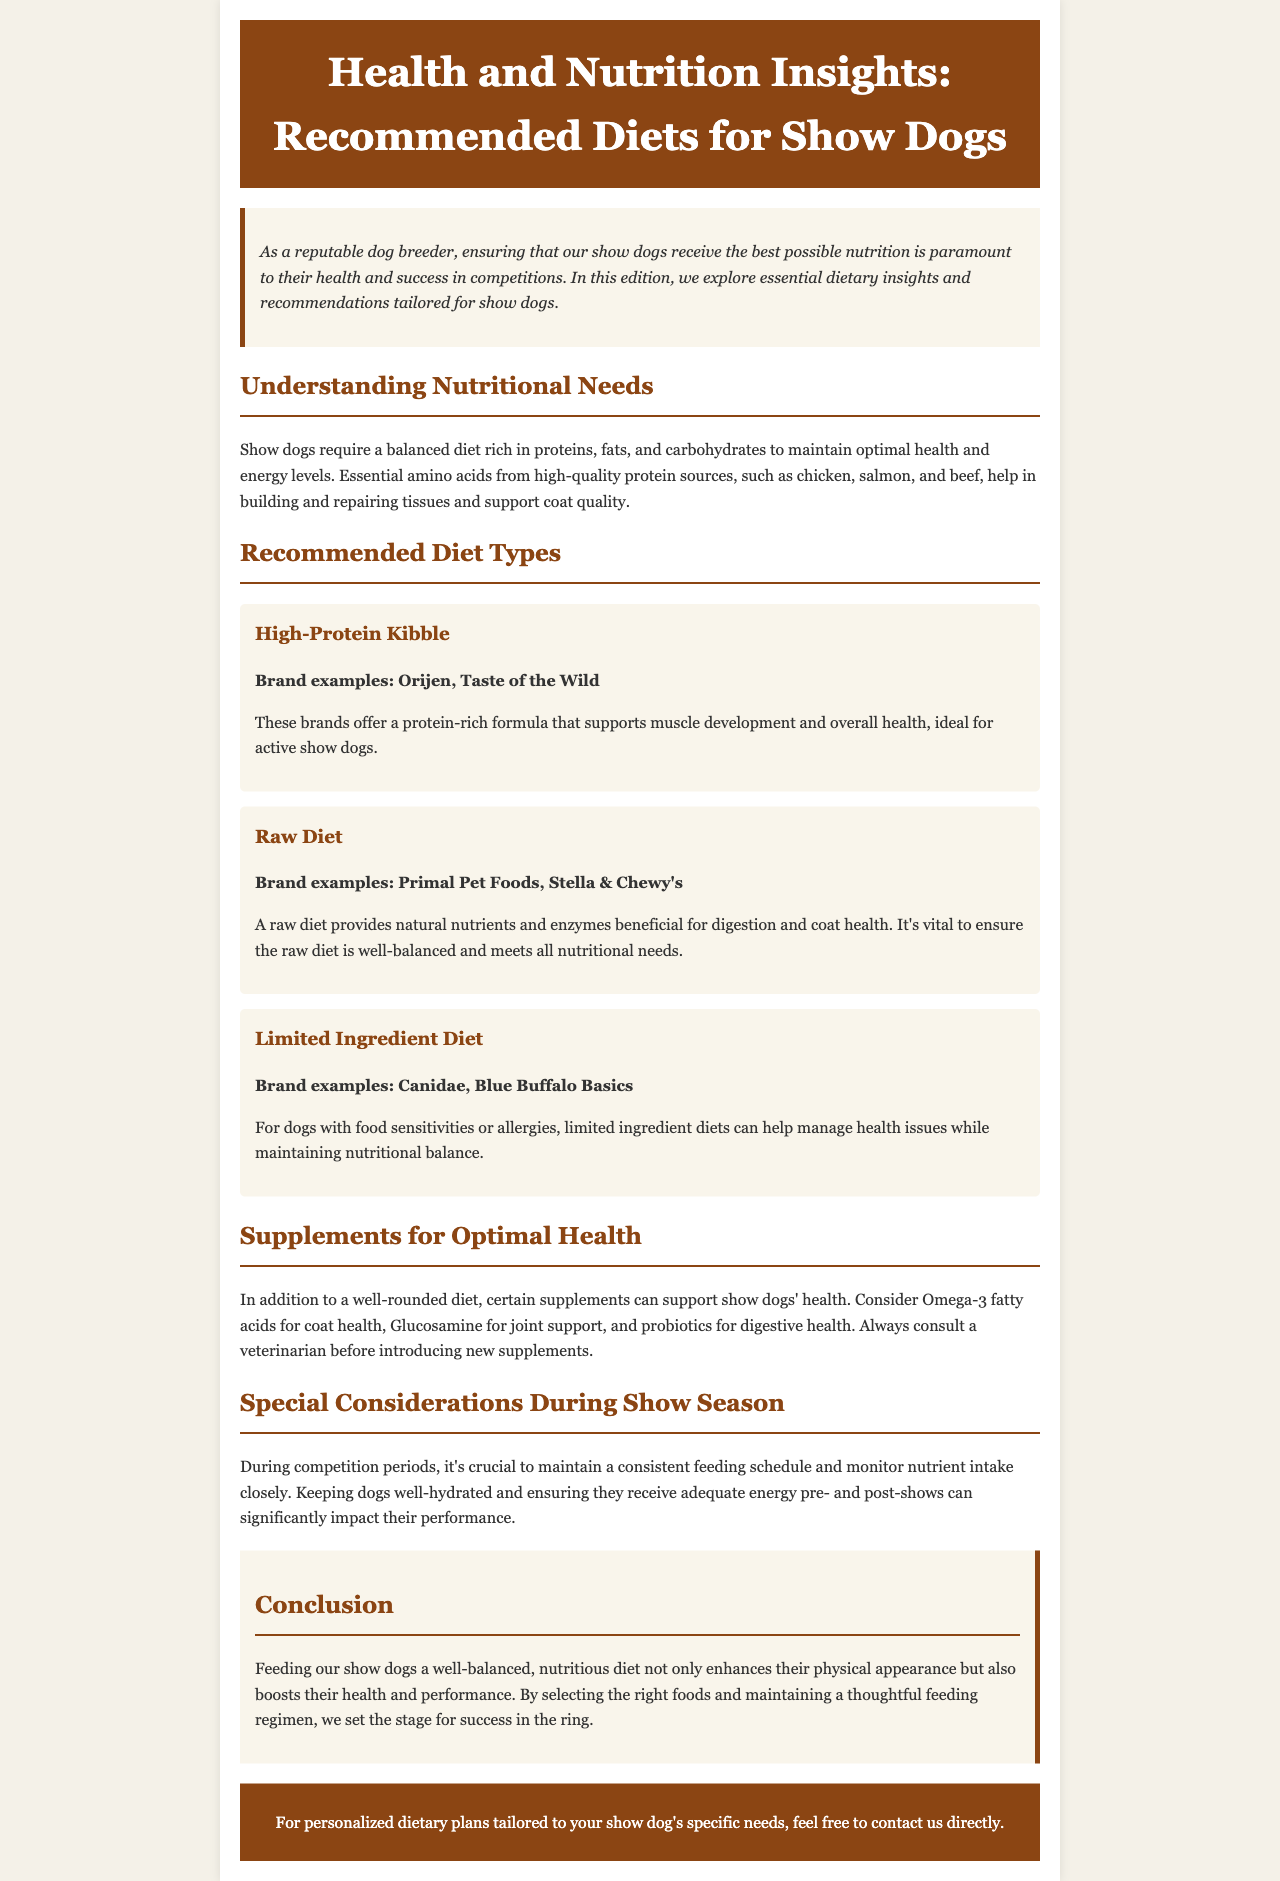What is the main focus of the newsletter? The introduction states that the newsletter focuses on essential dietary insights and recommendations tailored for show dogs.
Answer: dietary insights and recommendations tailored for show dogs Which diet type is recommended for dogs with food sensitivities? The Limited Ingredient Diet is mentioned as suitable for dogs with food sensitivities or allergies.
Answer: Limited Ingredient Diet Name one example of a raw diet brand. The section on raw diets provides brand examples, including Primal Pet Foods and Stella & Chewy's.
Answer: Primal Pet Foods What should be monitored closely during competition periods? The document advises monitoring nutrient intake closely during competition periods for show dogs.
Answer: nutrient intake Which supplement is suggested for joint support? The newsletter mentions Glucosamine as a recommended supplement for joint support.
Answer: Glucosamine What is the protein-rich formula ideal for active show dogs? The High-Protein Kibble diet is stated to support muscle development and is ideal for active show dogs.
Answer: High-Protein Kibble What essential nutrient is mentioned for coat health? Omega-3 fatty acids are highlighted as beneficial for coat health in show dogs.
Answer: Omega-3 fatty acids How should a feeding schedule be maintained during show season? The newsletter recommends maintaining a consistent feeding schedule during competition periods.
Answer: consistent feeding schedule 